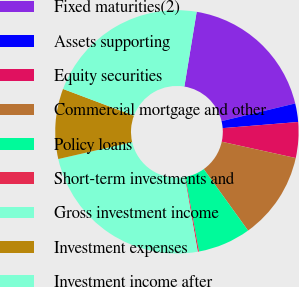<chart> <loc_0><loc_0><loc_500><loc_500><pie_chart><fcel>Fixed maturities(2)<fcel>Assets supporting<fcel>Equity securities<fcel>Commercial mortgage and other<fcel>Policy loans<fcel>Short-term investments and<fcel>Gross investment income<fcel>Investment expenses<fcel>Investment income after<nl><fcel>18.65%<fcel>2.46%<fcel>4.74%<fcel>11.61%<fcel>7.03%<fcel>0.17%<fcel>24.15%<fcel>9.32%<fcel>21.86%<nl></chart> 